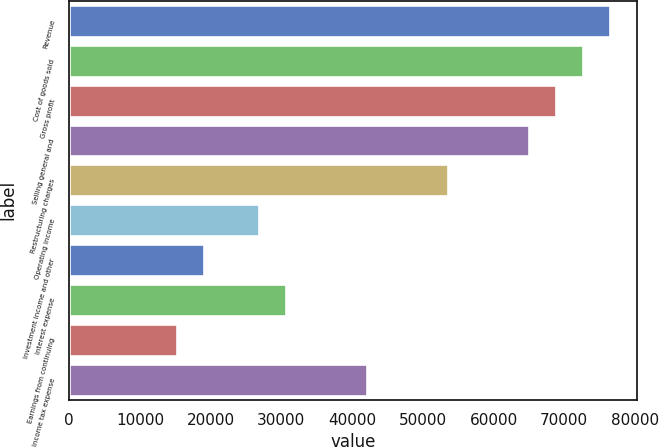<chart> <loc_0><loc_0><loc_500><loc_500><bar_chart><fcel>Revenue<fcel>Cost of goods sold<fcel>Gross profit<fcel>Selling general and<fcel>Restructuring charges<fcel>Operating income<fcel>Investment income and other<fcel>Interest expense<fcel>Earnings from continuing<fcel>Income tax expense<nl><fcel>76503.5<fcel>72678.4<fcel>68853.2<fcel>65028.1<fcel>53552.6<fcel>26776.6<fcel>19126.3<fcel>30601.7<fcel>15301.1<fcel>42077.2<nl></chart> 